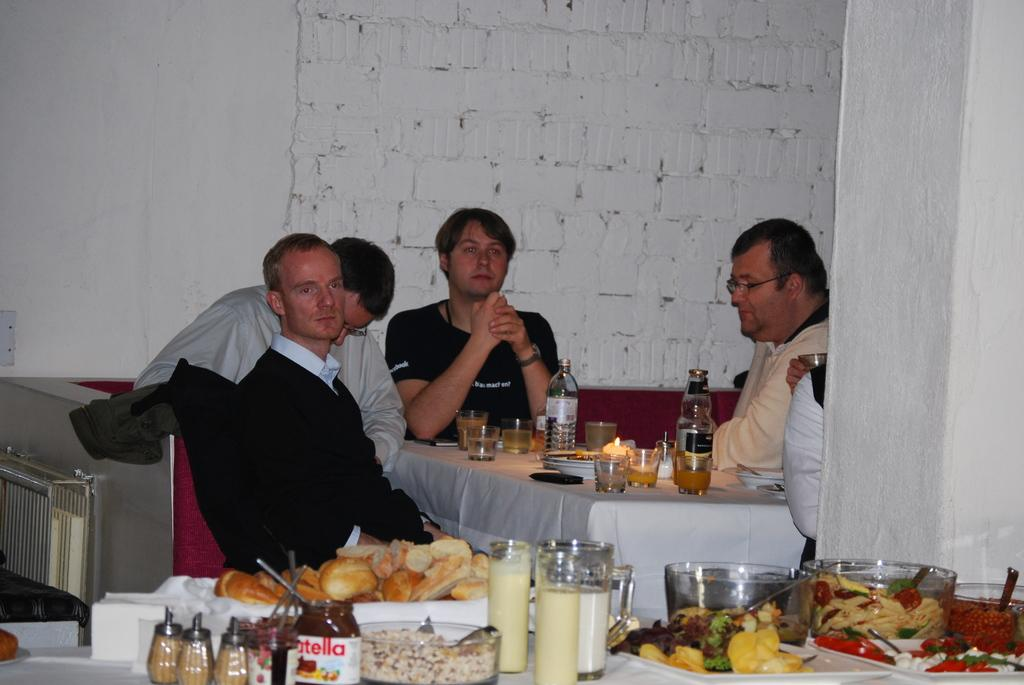<image>
Give a short and clear explanation of the subsequent image. People are seated at a table near another table with an open container of Nutella on it. 